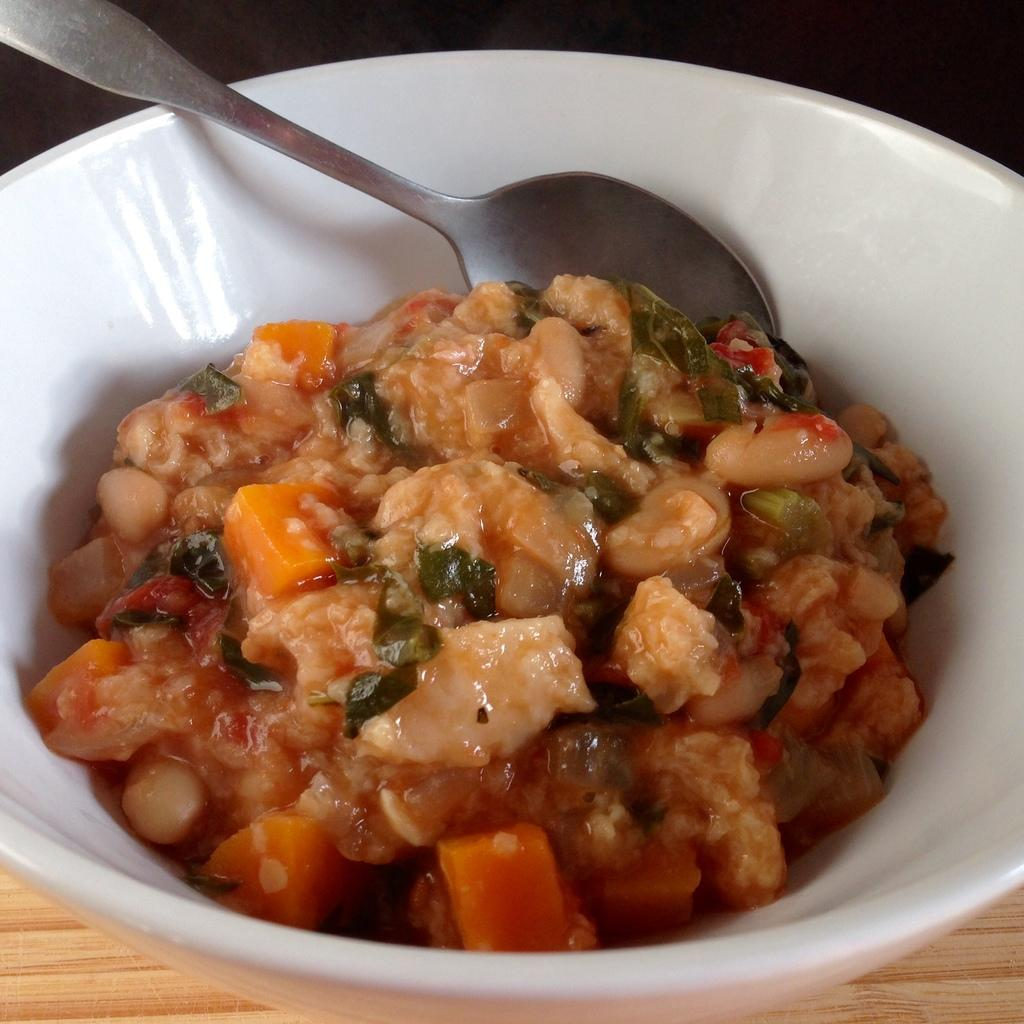What color is the bowl in the image? The bowl in the image is white. What is inside the bowl? There is a spoon and food in the bowl. What can be seen in the background of the image? The background of the image appears to be black. What type of range can be seen in the image? There is no range present in the image. How does the existence of the earth affect the contents of the bowl in the image? The existence of the earth does not directly affect the contents of the bowl in the image. 